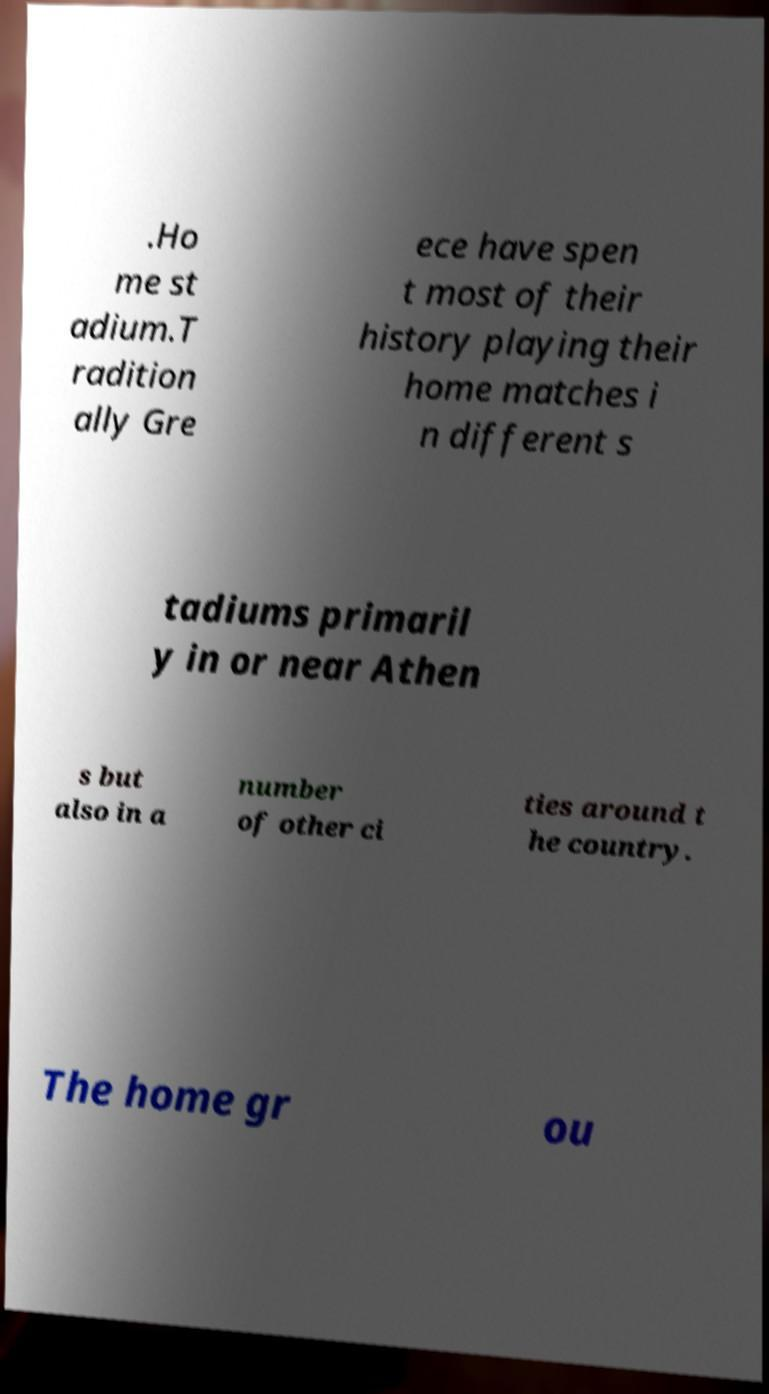What messages or text are displayed in this image? I need them in a readable, typed format. .Ho me st adium.T radition ally Gre ece have spen t most of their history playing their home matches i n different s tadiums primaril y in or near Athen s but also in a number of other ci ties around t he country. The home gr ou 